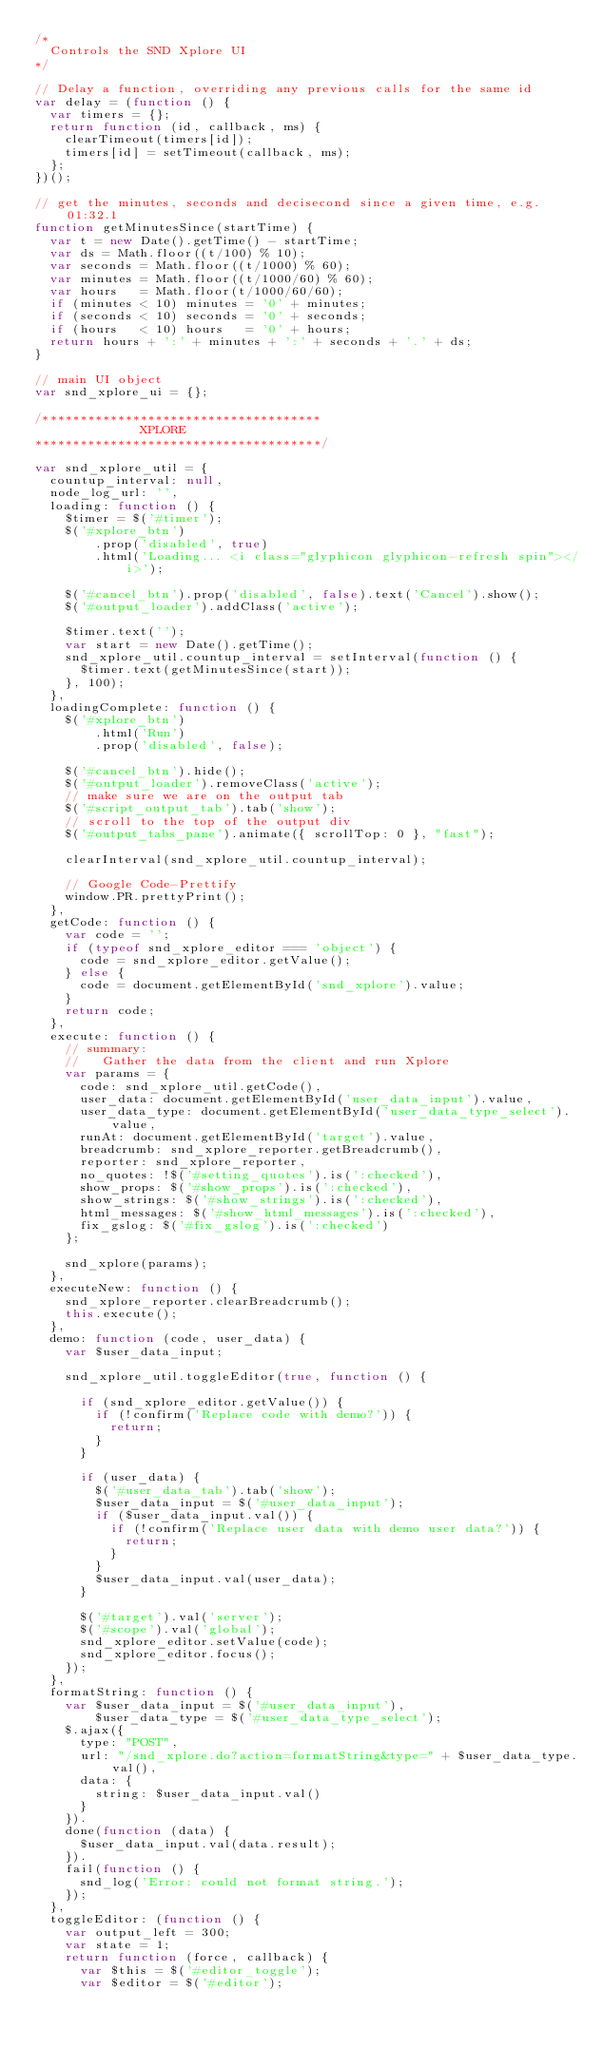<code> <loc_0><loc_0><loc_500><loc_500><_JavaScript_>/*
  Controls the SND Xplore UI
*/

// Delay a function, overriding any previous calls for the same id
var delay = (function () {
  var timers = {};
  return function (id, callback, ms) {
    clearTimeout(timers[id]);
    timers[id] = setTimeout(callback, ms);
  };
})();

// get the minutes, seconds and decisecond since a given time, e.g. 01:32.1
function getMinutesSince(startTime) {
  var t = new Date().getTime() - startTime;
  var ds = Math.floor((t/100) % 10);
  var seconds = Math.floor((t/1000) % 60);
  var minutes = Math.floor((t/1000/60) % 60);
  var hours   = Math.floor(t/1000/60/60);
  if (minutes < 10) minutes = '0' + minutes;
  if (seconds < 10) seconds = '0' + seconds;
  if (hours   < 10) hours   = '0' + hours;
  return hours + ':' + minutes + ':' + seconds + '.' + ds;
}

// main UI object
var snd_xplore_ui = {};

/*************************************
              XPLORE
**************************************/

var snd_xplore_util = {
  countup_interval: null,
  node_log_url: '',
  loading: function () {
    $timer = $('#timer');
    $('#xplore_btn')
        .prop('disabled', true)
        .html('Loading... <i class="glyphicon glyphicon-refresh spin"></i>');

    $('#cancel_btn').prop('disabled', false).text('Cancel').show();
    $('#output_loader').addClass('active');

    $timer.text('');
    var start = new Date().getTime();
    snd_xplore_util.countup_interval = setInterval(function () {
      $timer.text(getMinutesSince(start));
    }, 100);
  },
  loadingComplete: function () {
    $('#xplore_btn')
        .html('Run')
        .prop('disabled', false);

    $('#cancel_btn').hide();
    $('#output_loader').removeClass('active');
    // make sure we are on the output tab
    $('#script_output_tab').tab('show');
    // scroll to the top of the output div
    $('#output_tabs_pane').animate({ scrollTop: 0 }, "fast");

    clearInterval(snd_xplore_util.countup_interval);

    // Google Code-Prettify
    window.PR.prettyPrint();
  },
  getCode: function () {
    var code = '';
    if (typeof snd_xplore_editor === 'object') {
      code = snd_xplore_editor.getValue();
    } else {
      code = document.getElementById('snd_xplore').value;
    }
    return code;
  },
  execute: function () {
    // summary:
    //   Gather the data from the client and run Xplore
    var params = {
      code: snd_xplore_util.getCode(),
      user_data: document.getElementById('user_data_input').value,
      user_data_type: document.getElementById('user_data_type_select').value,
      runAt: document.getElementById('target').value,
      breadcrumb: snd_xplore_reporter.getBreadcrumb(),
      reporter: snd_xplore_reporter,
      no_quotes: !$('#setting_quotes').is(':checked'),
      show_props: $('#show_props').is(':checked'),
      show_strings: $('#show_strings').is(':checked'),
      html_messages: $('#show_html_messages').is(':checked'),
      fix_gslog: $('#fix_gslog').is(':checked')
    };

    snd_xplore(params);
  },
  executeNew: function () {
    snd_xplore_reporter.clearBreadcrumb();
    this.execute();
  },
  demo: function (code, user_data) {
    var $user_data_input;

    snd_xplore_util.toggleEditor(true, function () {

      if (snd_xplore_editor.getValue()) {
        if (!confirm('Replace code with demo?')) {
          return;
        }
      }

      if (user_data) {
        $('#user_data_tab').tab('show');
        $user_data_input = $('#user_data_input');
        if ($user_data_input.val()) {
          if (!confirm('Replace user data with demo user data?')) {
            return;
          }
        }
        $user_data_input.val(user_data);
      }

      $('#target').val('server');
      $('#scope').val('global');
      snd_xplore_editor.setValue(code);
      snd_xplore_editor.focus();
    });
  },
  formatString: function () {
    var $user_data_input = $('#user_data_input'),
        $user_data_type = $('#user_data_type_select');
    $.ajax({
      type: "POST",
      url: "/snd_xplore.do?action=formatString&type=" + $user_data_type.val(),
      data: {
        string: $user_data_input.val()
      }
    }).
    done(function (data) {
      $user_data_input.val(data.result);
    }).
    fail(function () {
      snd_log('Error: could not format string.');
    });
  },
  toggleEditor: (function () {
    var output_left = 300;
    var state = 1;
    return function (force, callback) {
      var $this = $('#editor_toggle');
      var $editor = $('#editor');</code> 